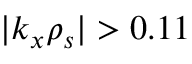<formula> <loc_0><loc_0><loc_500><loc_500>| k _ { x } \rho _ { s } | > 0 . 1 1</formula> 